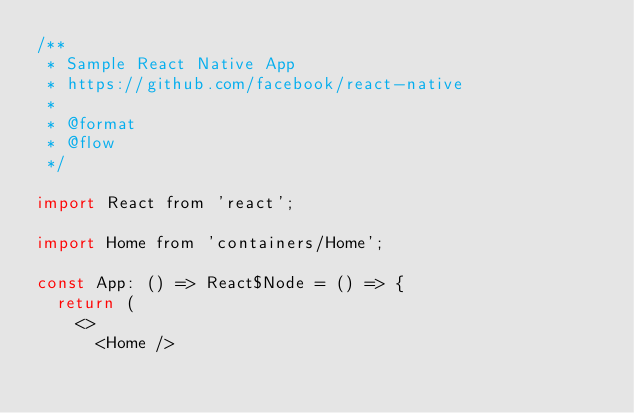<code> <loc_0><loc_0><loc_500><loc_500><_JavaScript_>/**
 * Sample React Native App
 * https://github.com/facebook/react-native
 *
 * @format
 * @flow
 */

import React from 'react';

import Home from 'containers/Home';

const App: () => React$Node = () => {
  return (
    <>
      <Home /></code> 